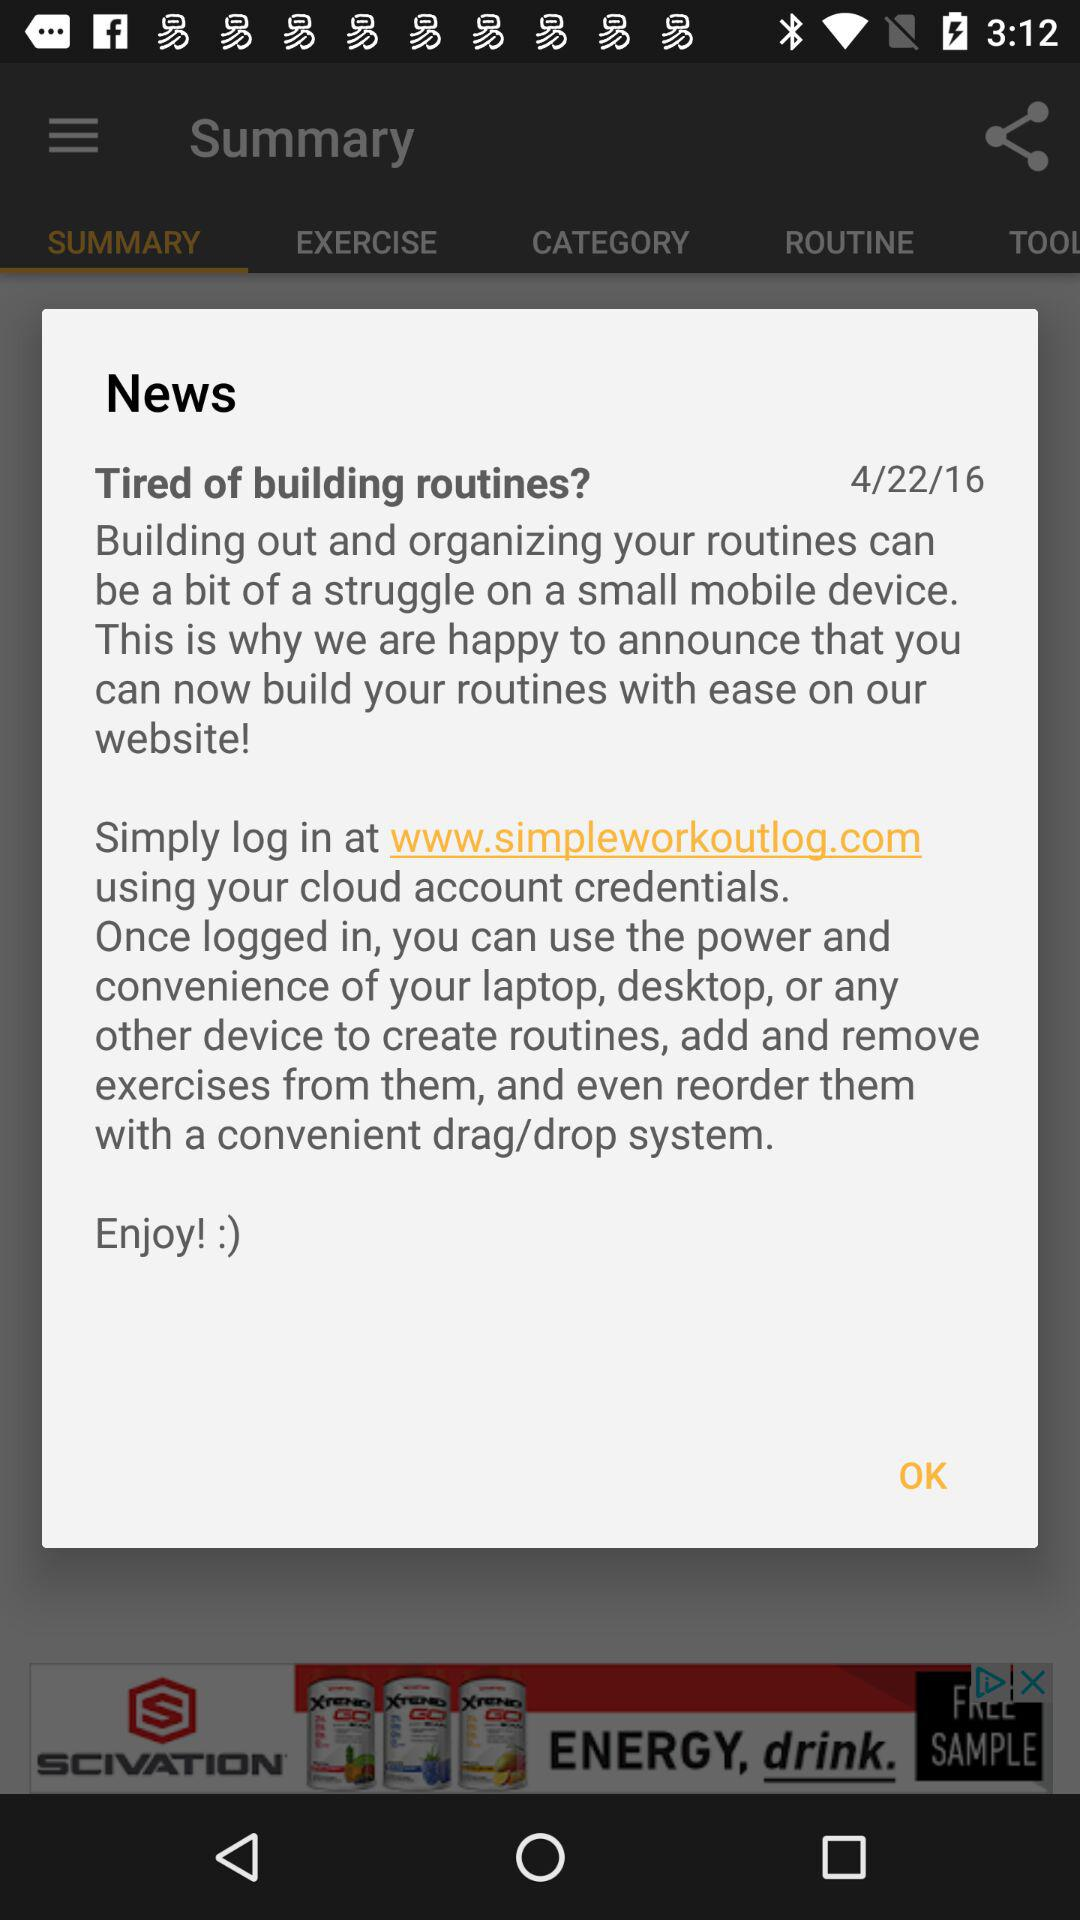Where do we have to log in? You have to log in at www.simpleworkoutlog.com. 